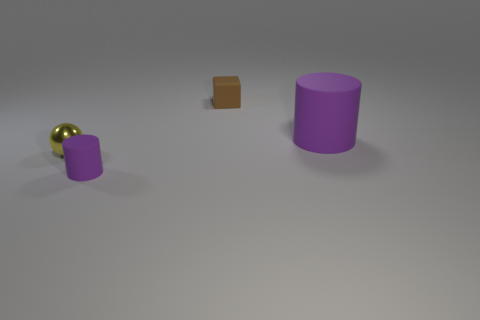Add 2 big objects. How many objects exist? 6 Subtract 1 balls. How many balls are left? 0 Subtract all cubes. How many objects are left? 3 Subtract all big green matte spheres. Subtract all cubes. How many objects are left? 3 Add 1 spheres. How many spheres are left? 2 Add 3 tiny green shiny cylinders. How many tiny green shiny cylinders exist? 3 Subtract 0 gray cylinders. How many objects are left? 4 Subtract all cyan cubes. Subtract all purple spheres. How many cubes are left? 1 Subtract all gray cylinders. How many green spheres are left? 0 